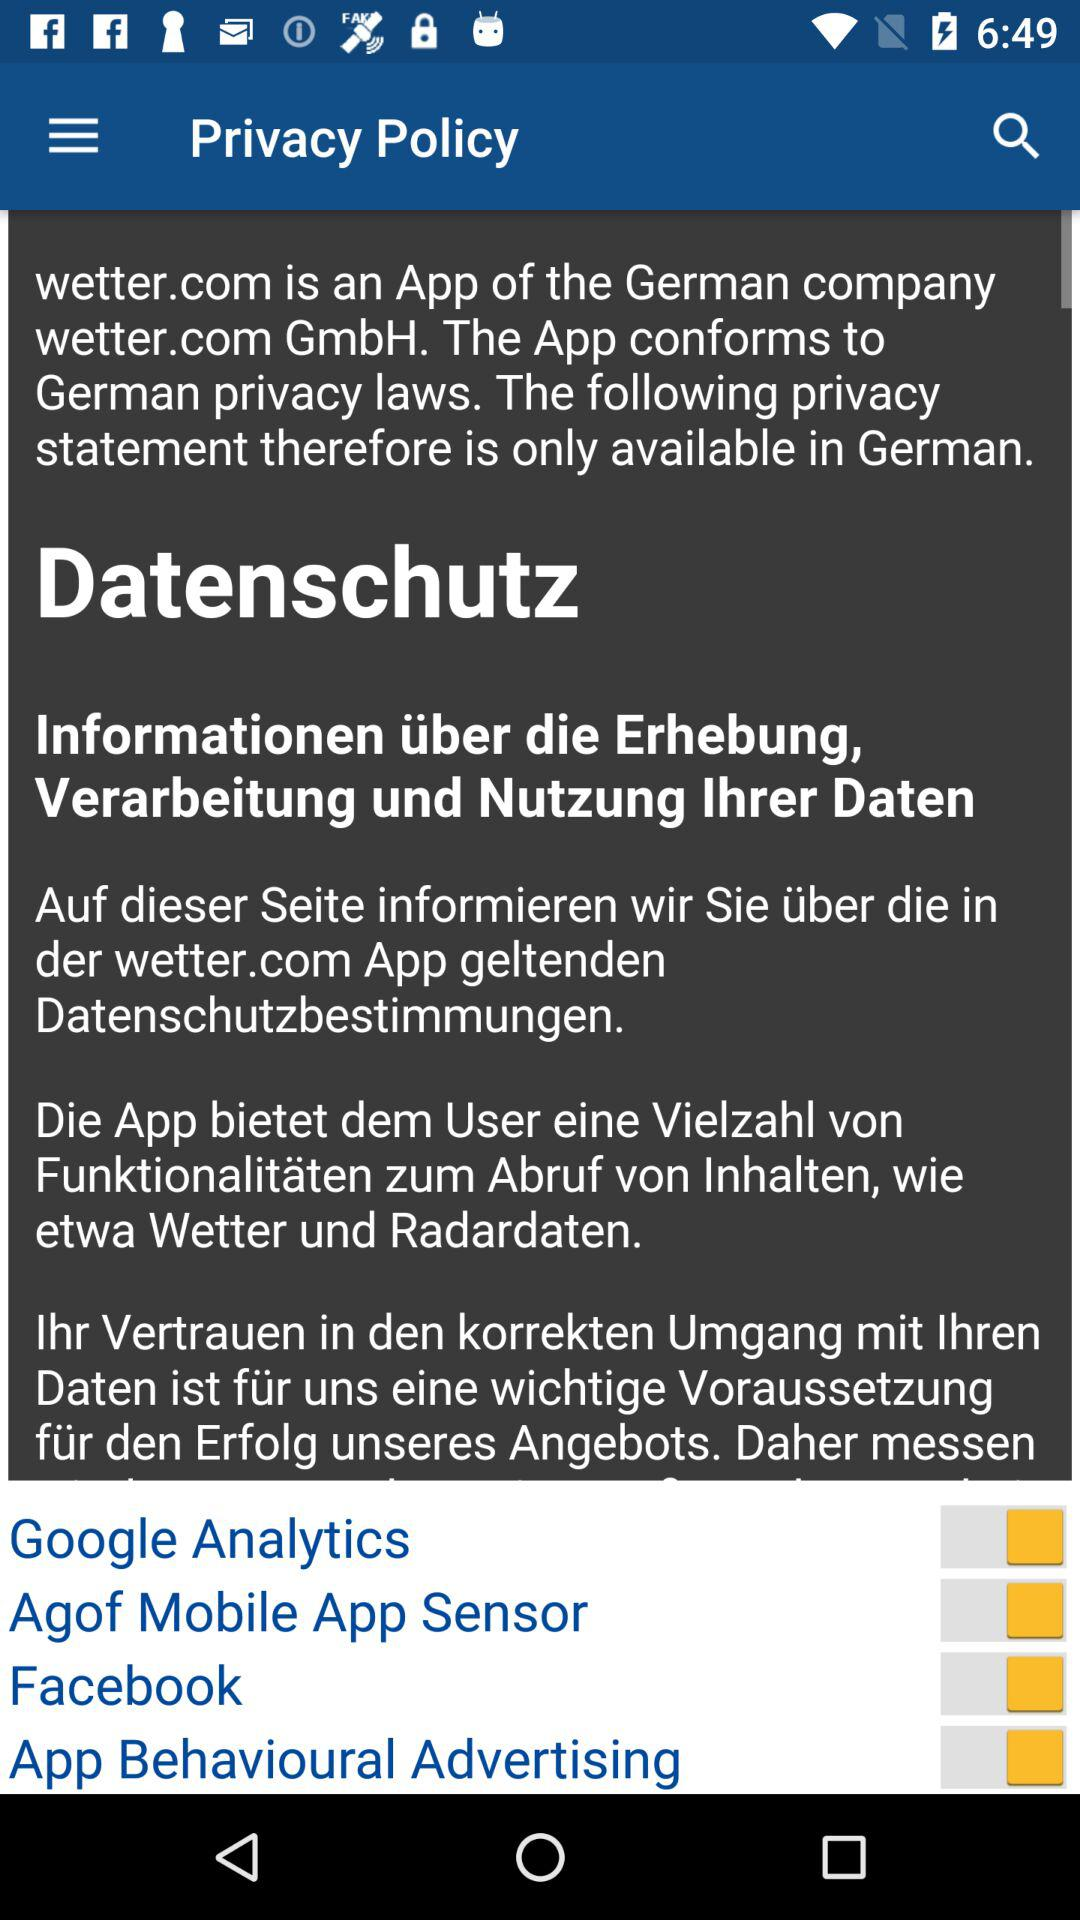Which country belongs to wetter.com? The country is German. 